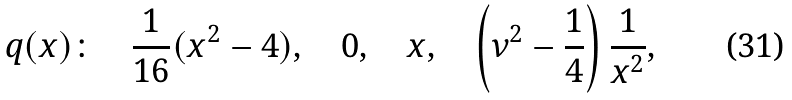Convert formula to latex. <formula><loc_0><loc_0><loc_500><loc_500>q ( x ) \colon \quad \frac { 1 } { 1 6 } ( x ^ { 2 } - 4 ) , \quad 0 , \quad x , \quad \left ( \nu ^ { 2 } - \frac { 1 } { 4 } \right ) \frac { 1 } { x ^ { 2 } } ,</formula> 